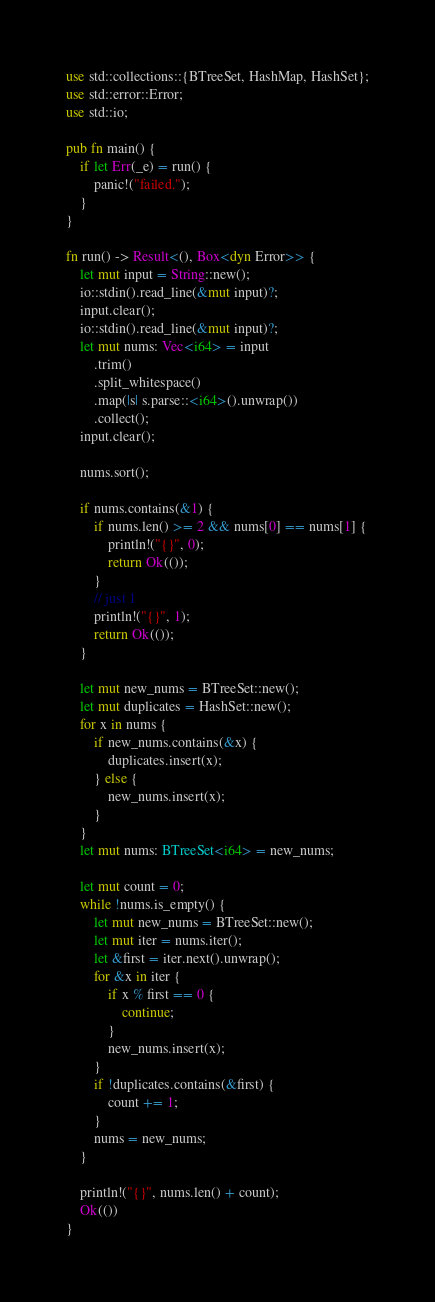Convert code to text. <code><loc_0><loc_0><loc_500><loc_500><_Rust_>use std::collections::{BTreeSet, HashMap, HashSet};
use std::error::Error;
use std::io;

pub fn main() {
    if let Err(_e) = run() {
        panic!("failed.");
    }
}

fn run() -> Result<(), Box<dyn Error>> {
    let mut input = String::new();
    io::stdin().read_line(&mut input)?;
    input.clear();
    io::stdin().read_line(&mut input)?;
    let mut nums: Vec<i64> = input
        .trim()
        .split_whitespace()
        .map(|s| s.parse::<i64>().unwrap())
        .collect();
    input.clear();

    nums.sort();

    if nums.contains(&1) {
        if nums.len() >= 2 && nums[0] == nums[1] {
            println!("{}", 0);
            return Ok(());
        }
        // just 1
        println!("{}", 1);
        return Ok(());
    }

    let mut new_nums = BTreeSet::new();
    let mut duplicates = HashSet::new();
    for x in nums {
        if new_nums.contains(&x) {
            duplicates.insert(x);
        } else {
            new_nums.insert(x);
        }
    }
    let mut nums: BTreeSet<i64> = new_nums;

    let mut count = 0;
    while !nums.is_empty() {
        let mut new_nums = BTreeSet::new();
        let mut iter = nums.iter();
        let &first = iter.next().unwrap();
        for &x in iter {
            if x % first == 0 {
                continue;
            }
            new_nums.insert(x);
        }
        if !duplicates.contains(&first) {
            count += 1;
        }
        nums = new_nums;
    }

    println!("{}", nums.len() + count);
    Ok(())
}
</code> 